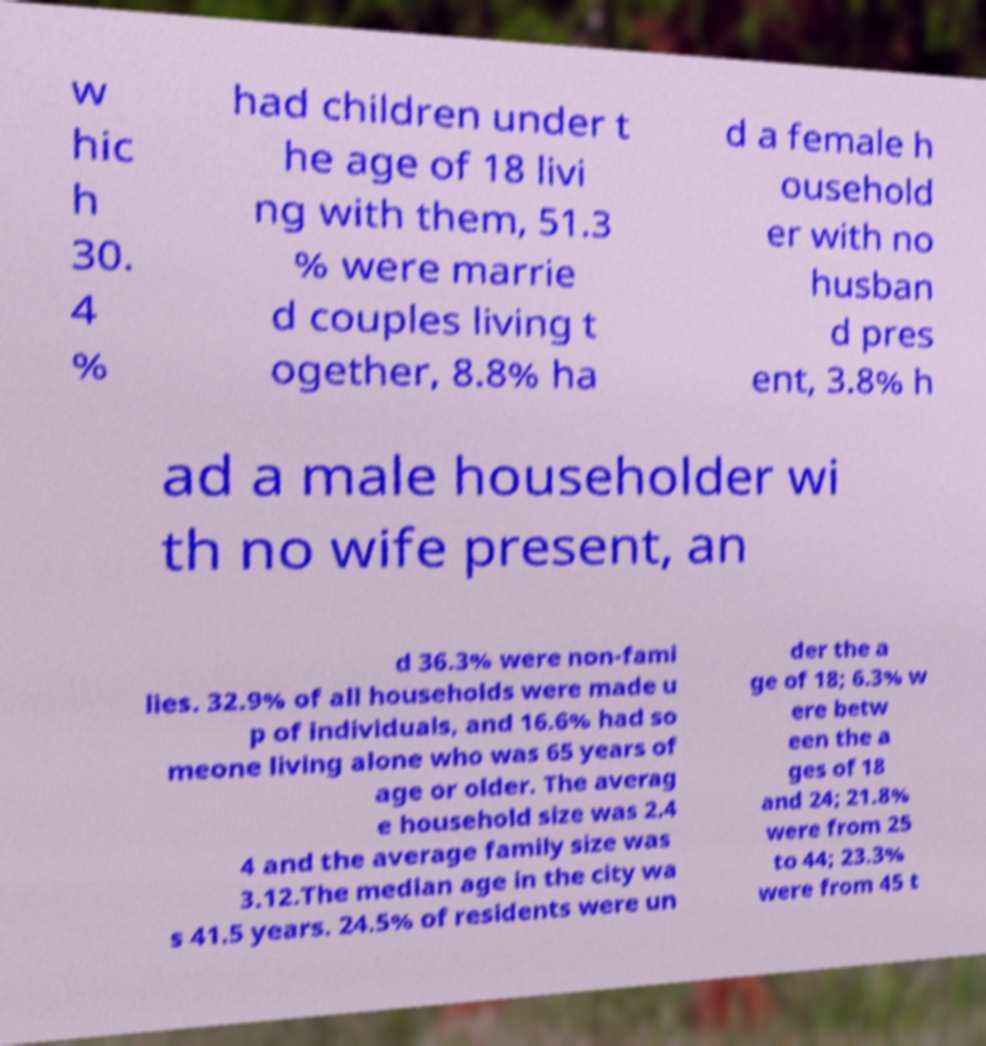Please identify and transcribe the text found in this image. w hic h 30. 4 % had children under t he age of 18 livi ng with them, 51.3 % were marrie d couples living t ogether, 8.8% ha d a female h ousehold er with no husban d pres ent, 3.8% h ad a male householder wi th no wife present, an d 36.3% were non-fami lies. 32.9% of all households were made u p of individuals, and 16.6% had so meone living alone who was 65 years of age or older. The averag e household size was 2.4 4 and the average family size was 3.12.The median age in the city wa s 41.5 years. 24.5% of residents were un der the a ge of 18; 6.3% w ere betw een the a ges of 18 and 24; 21.8% were from 25 to 44; 23.3% were from 45 t 